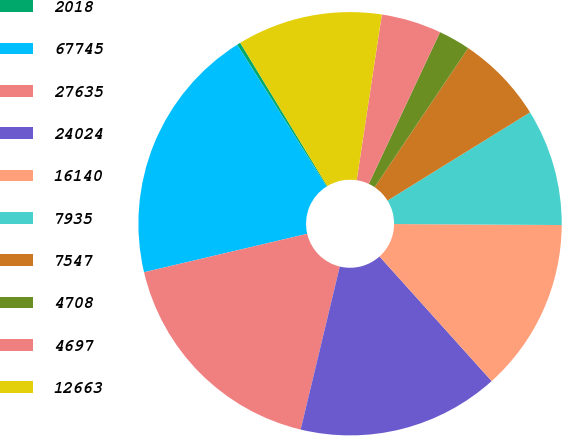Convert chart to OTSL. <chart><loc_0><loc_0><loc_500><loc_500><pie_chart><fcel>2018<fcel>67745<fcel>27635<fcel>24024<fcel>16140<fcel>7935<fcel>7547<fcel>4708<fcel>4697<fcel>12663<nl><fcel>0.27%<fcel>19.73%<fcel>17.57%<fcel>15.41%<fcel>13.24%<fcel>8.92%<fcel>6.76%<fcel>2.43%<fcel>4.59%<fcel>11.08%<nl></chart> 